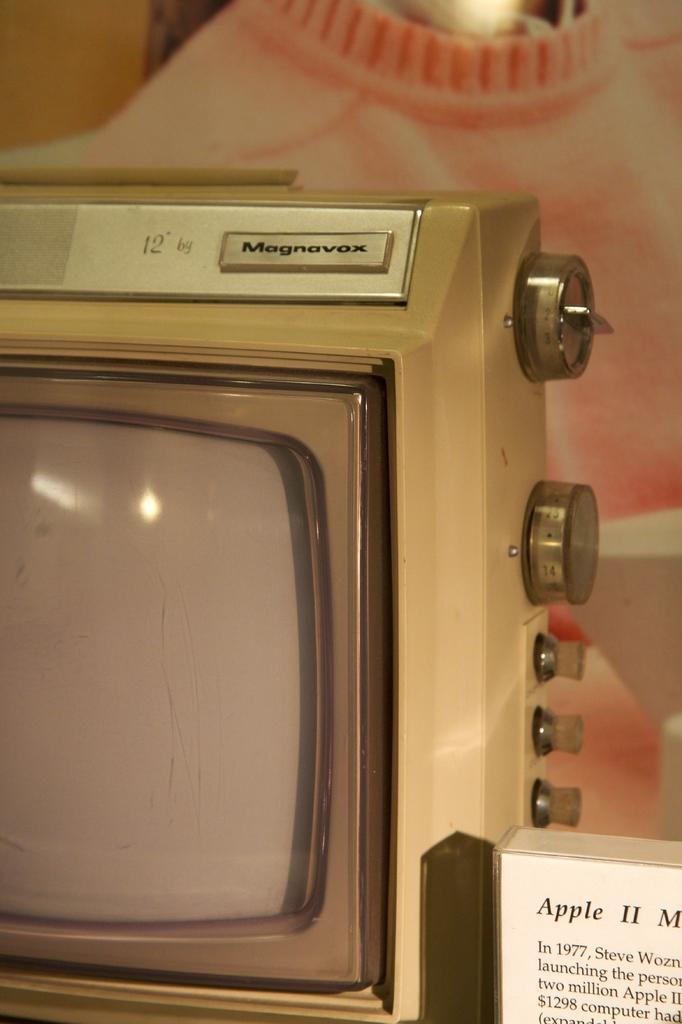Could you give a brief overview of what you see in this image? In this image in the front there is a board with some text and numbers written on it. In the center there is a television and on the top of the television there is some text which is visible. In the background there is an object which is pink in colour. 